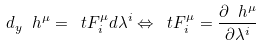Convert formula to latex. <formula><loc_0><loc_0><loc_500><loc_500>d _ { y } \ h ^ { \mu } = \ t F ^ { \mu } _ { i } d \lambda ^ { i } \Leftrightarrow \ t F ^ { \mu } _ { i } = \frac { \partial \ h ^ { \mu } } { \partial \lambda ^ { i } }</formula> 